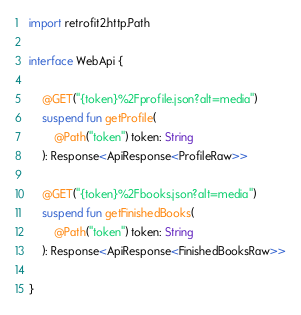Convert code to text. <code><loc_0><loc_0><loc_500><loc_500><_Kotlin_>import retrofit2.http.Path

interface WebApi {

    @GET("{token}%2Fprofile.json?alt=media")
    suspend fun getProfile(
        @Path("token") token: String
    ): Response<ApiResponse<ProfileRaw>>

    @GET("{token}%2Fbooks.json?alt=media")
    suspend fun getFinishedBooks(
        @Path("token") token: String
    ): Response<ApiResponse<FinishedBooksRaw>>

}</code> 